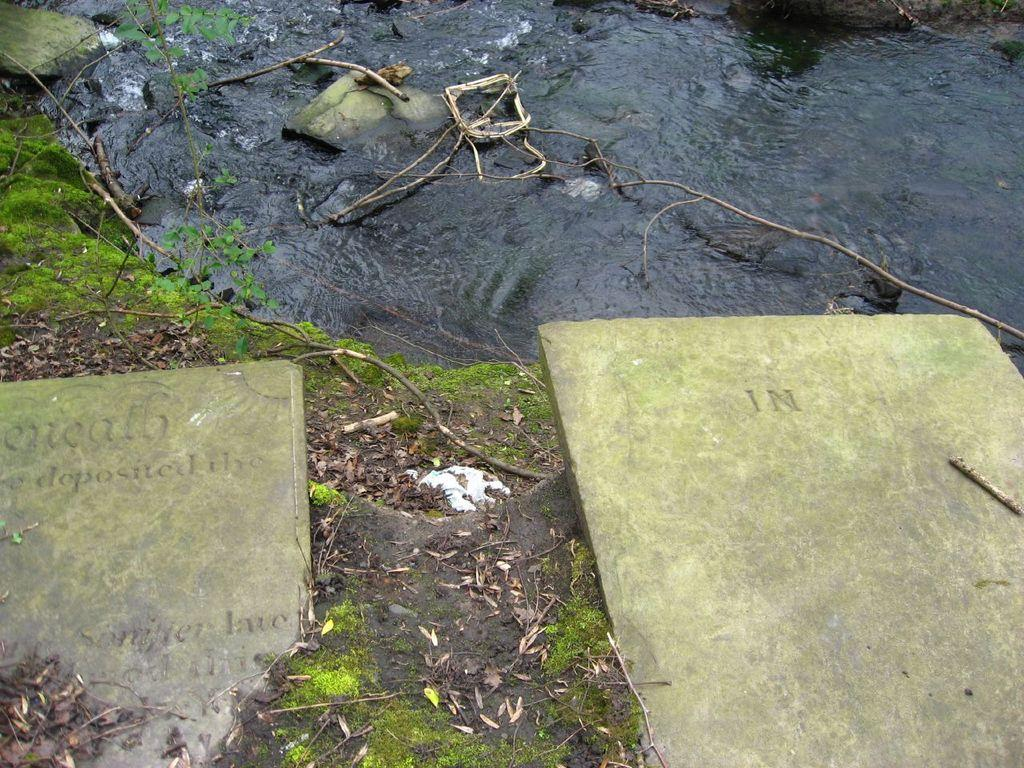What is the primary element visible in the image? There is water in the image. What other objects can be seen in the image? There are stones in the image. What type of gold jewelry is the bee wearing in the image? There is no bee or gold jewelry present in the image. How many horses can be seen in the image? There are no horses present in the image. 